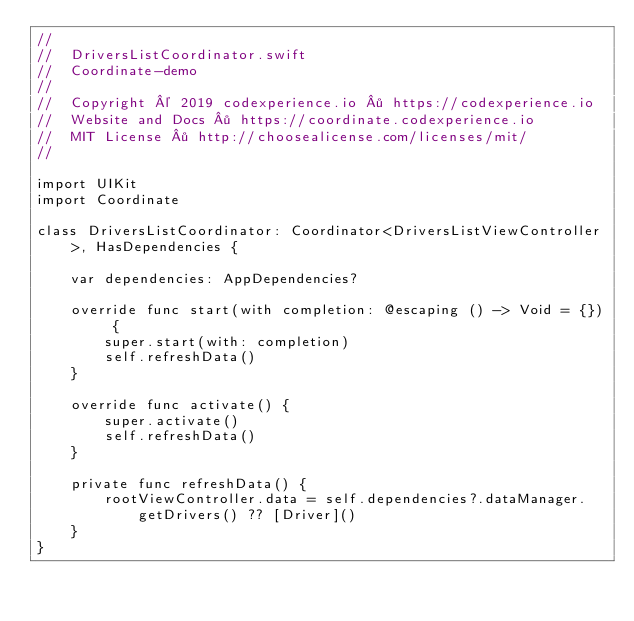<code> <loc_0><loc_0><loc_500><loc_500><_Swift_>//
//  DriversListCoordinator.swift
//  Coordinate-demo
//
//  Copyright © 2019 codexperience.io · https://codexperience.io
//  Website and Docs · https://coordinate.codexperience.io
//  MIT License · http://choosealicense.com/licenses/mit/
//

import UIKit
import Coordinate

class DriversListCoordinator: Coordinator<DriversListViewController>, HasDependencies {
        
    var dependencies: AppDependencies?
    
    override func start(with completion: @escaping () -> Void = {}) {
        super.start(with: completion)
        self.refreshData()
    }
    
    override func activate() {
        super.activate()
        self.refreshData()
    }
    
    private func refreshData() {
        rootViewController.data = self.dependencies?.dataManager.getDrivers() ?? [Driver]()
    }
}
</code> 